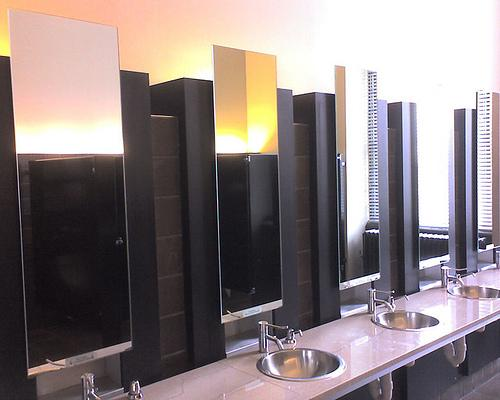What type of building is this bathroom likely to be in? office 